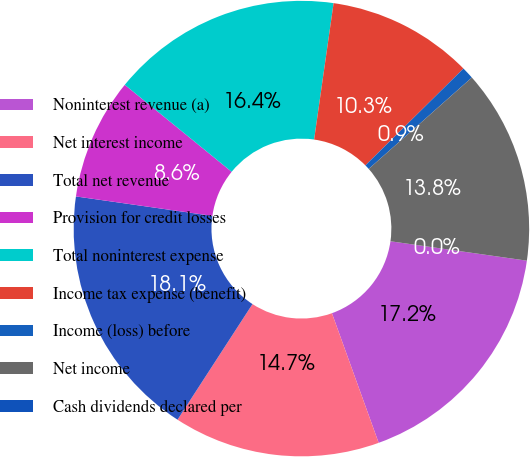Convert chart to OTSL. <chart><loc_0><loc_0><loc_500><loc_500><pie_chart><fcel>Noninterest revenue (a)<fcel>Net interest income<fcel>Total net revenue<fcel>Provision for credit losses<fcel>Total noninterest expense<fcel>Income tax expense (benefit)<fcel>Income (loss) before<fcel>Net income<fcel>Cash dividends declared per<nl><fcel>17.24%<fcel>14.66%<fcel>18.1%<fcel>8.62%<fcel>16.38%<fcel>10.34%<fcel>0.86%<fcel>13.79%<fcel>0.0%<nl></chart> 